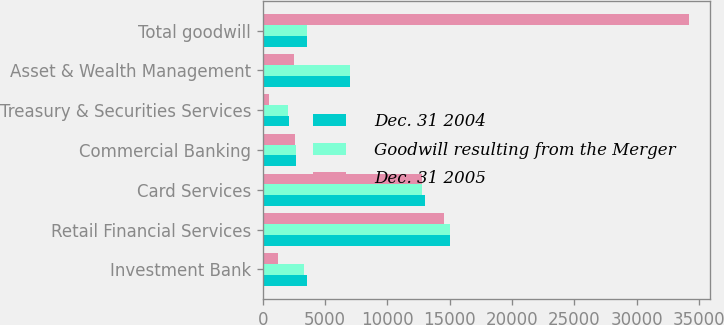<chart> <loc_0><loc_0><loc_500><loc_500><stacked_bar_chart><ecel><fcel>Investment Bank<fcel>Retail Financial Services<fcel>Card Services<fcel>Commercial Banking<fcel>Treasury & Securities Services<fcel>Asset & Wealth Management<fcel>Total goodwill<nl><fcel>Dec. 31 2004<fcel>3531<fcel>14991<fcel>12984<fcel>2651<fcel>2062<fcel>7025<fcel>3531<nl><fcel>Goodwill resulting from the Merger<fcel>3309<fcel>15022<fcel>12781<fcel>2650<fcel>2044<fcel>7020<fcel>3531<nl><fcel>Dec. 31 2005<fcel>1179<fcel>14576<fcel>12802<fcel>2599<fcel>465<fcel>2539<fcel>34160<nl></chart> 